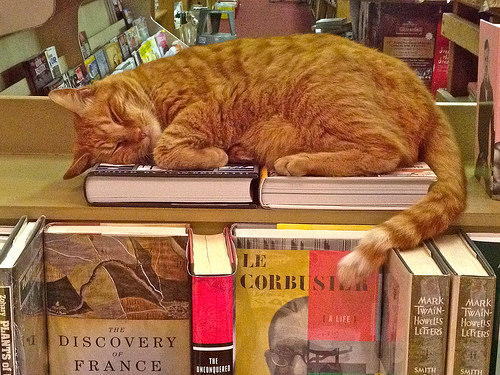<image>
Can you confirm if the cat is on the shelf? Yes. Looking at the image, I can see the cat is positioned on top of the shelf, with the shelf providing support. 